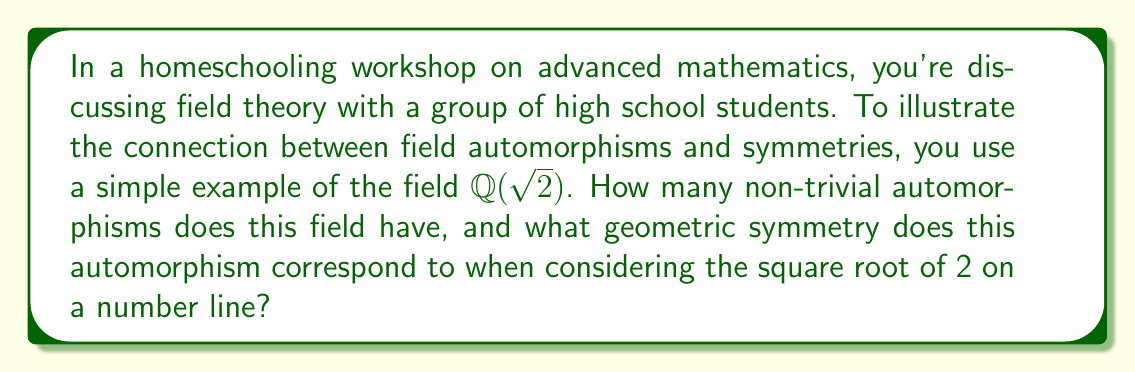Can you solve this math problem? Let's approach this step-by-step:

1) First, recall that $\mathbb{Q}(\sqrt{2})$ is the field obtained by adjoining $\sqrt{2}$ to the rational numbers.

2) An automorphism of a field is a bijective homomorphism from the field to itself. In other words, it's a way of rearranging the elements of the field while preserving its structure.

3) For $\mathbb{Q}(\sqrt{2})$, any automorphism must:
   a) Fix all rational numbers (because they must map to themselves)
   b) Either fix $\sqrt{2}$ or map it to its negative (because these are the only elements that square to 2)

4) This gives us two possibilities for an automorphism $\sigma$:
   a) The identity automorphism: $\sigma(a + b\sqrt{2}) = a + b\sqrt{2}$
   b) The non-trivial automorphism: $\sigma(a + b\sqrt{2}) = a - b\sqrt{2}$

5) Therefore, there is only one non-trivial automorphism of $\mathbb{Q}(\sqrt{2})$.

6) Geometrically, if we consider $\sqrt{2}$ on a number line, this automorphism corresponds to a reflection about the origin. It maps $\sqrt{2}$ to $-\sqrt{2}$, which is the reflection of $\sqrt{2}$ across the y-axis.

7) This reflection is a symmetry of the number line that preserves the field structure of $\mathbb{Q}(\sqrt{2})$.
Answer: 1 non-trivial automorphism; reflection symmetry about the origin 